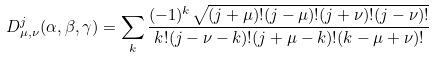Convert formula to latex. <formula><loc_0><loc_0><loc_500><loc_500>D _ { \mu , \nu } ^ { j } ( \alpha , \beta , \gamma ) = \sum _ { k } \frac { ( - 1 ) ^ { k } \sqrt { ( j + \mu ) ! ( j - \mu ) ! ( j + \nu ) ! ( j - \nu ) ! } } { k ! ( j - \nu - k ) ! ( j + \mu - k ) ! ( k - \mu + \nu ) ! }</formula> 